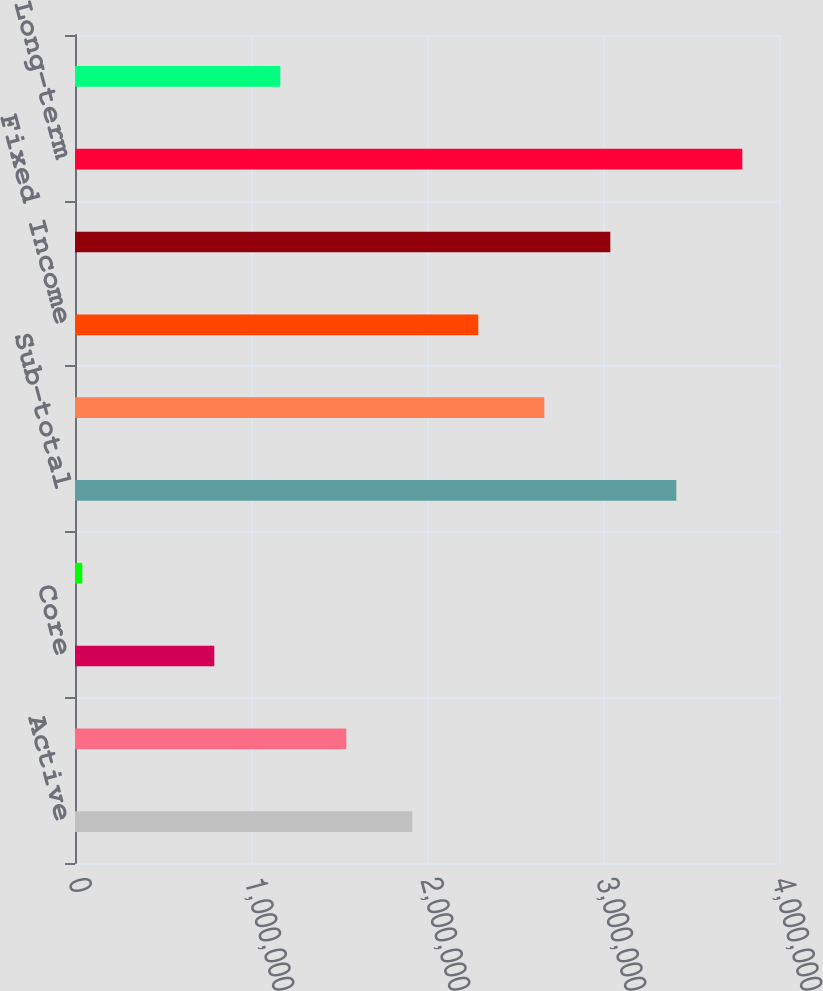Convert chart. <chart><loc_0><loc_0><loc_500><loc_500><bar_chart><fcel>Active<fcel>Multi-asset class<fcel>Core<fcel>Currency and commodities (9)<fcel>Sub-total<fcel>Equity<fcel>Fixed Income<fcel>Sub-total Non-ETF Index<fcel>Long-term<fcel>Cash management<nl><fcel>1.91651e+06<fcel>1.54149e+06<fcel>791460<fcel>41428<fcel>3.41657e+06<fcel>2.66654e+06<fcel>2.29152e+06<fcel>3.04156e+06<fcel>3.79159e+06<fcel>1.16648e+06<nl></chart> 